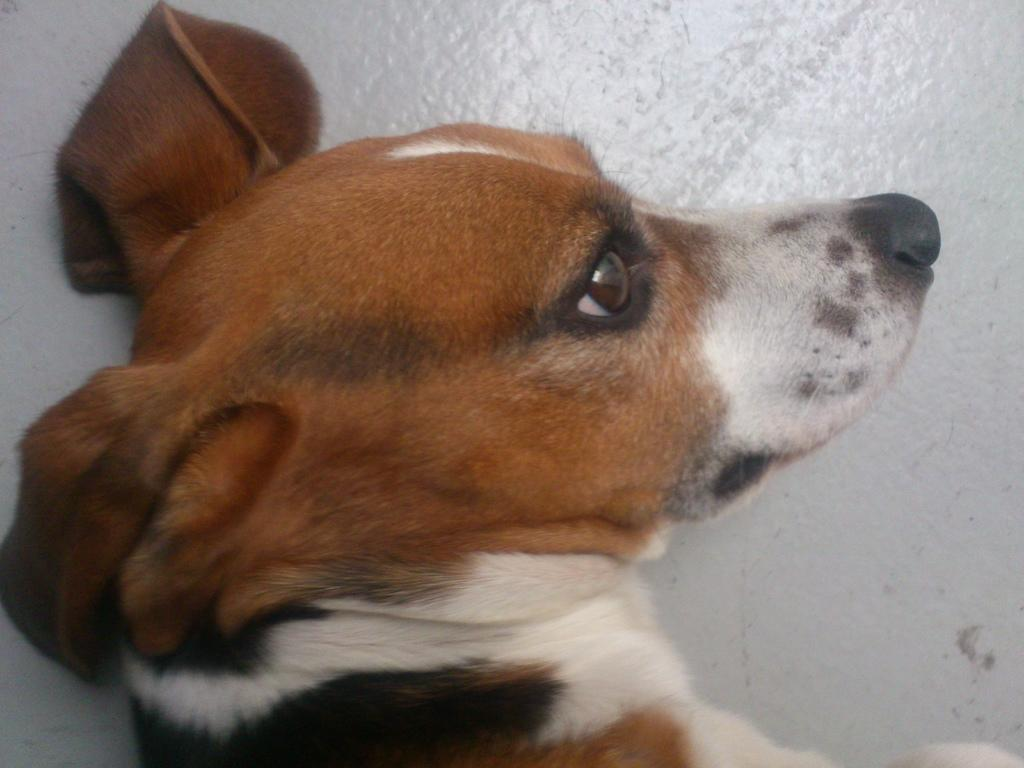What animal is present in the image? There is a dog in the image. Where is the dog located? The dog is lying on a white surface. What color is the surface the dog is lying on? The surface is white. What type of mouthwash is the dog using in the image? There is no mouthwash present in the image, and the dog is not using any. 